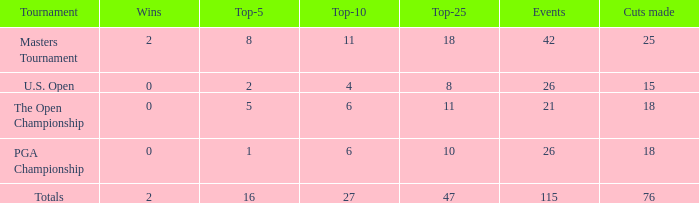What is the average Top-10 with a greater than 11 Top-25 and a less than 2 wins? None. 